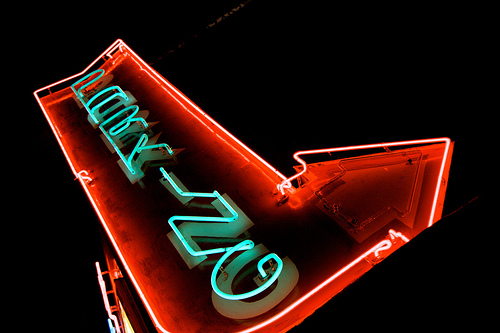<image>
Can you confirm if the sign is under the sky? Yes. The sign is positioned underneath the sky, with the sky above it in the vertical space. Is the letters in the light? Yes. The letters is contained within or inside the light, showing a containment relationship. 